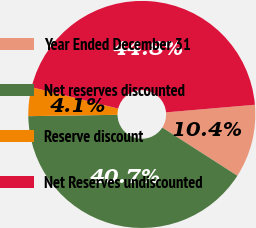Convert chart to OTSL. <chart><loc_0><loc_0><loc_500><loc_500><pie_chart><fcel>Year Ended December 31<fcel>Net reserves discounted<fcel>Reserve discount<fcel>Net Reserves undiscounted<nl><fcel>10.44%<fcel>40.68%<fcel>4.1%<fcel>44.78%<nl></chart> 